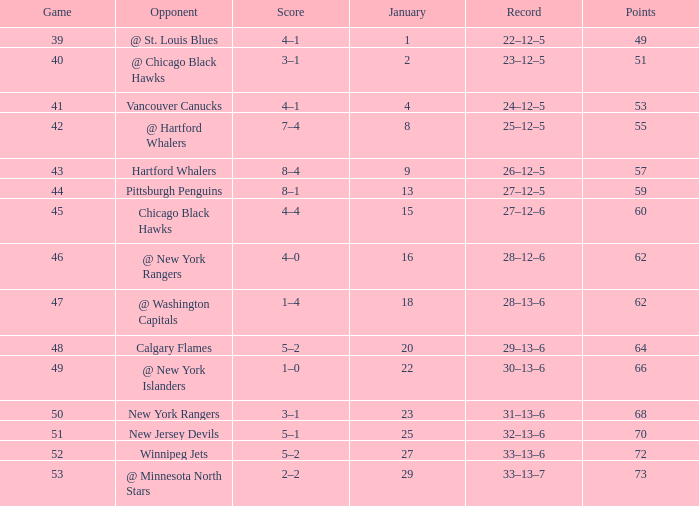Which January has a Score of 7–4, and a Game smaller than 42? None. 